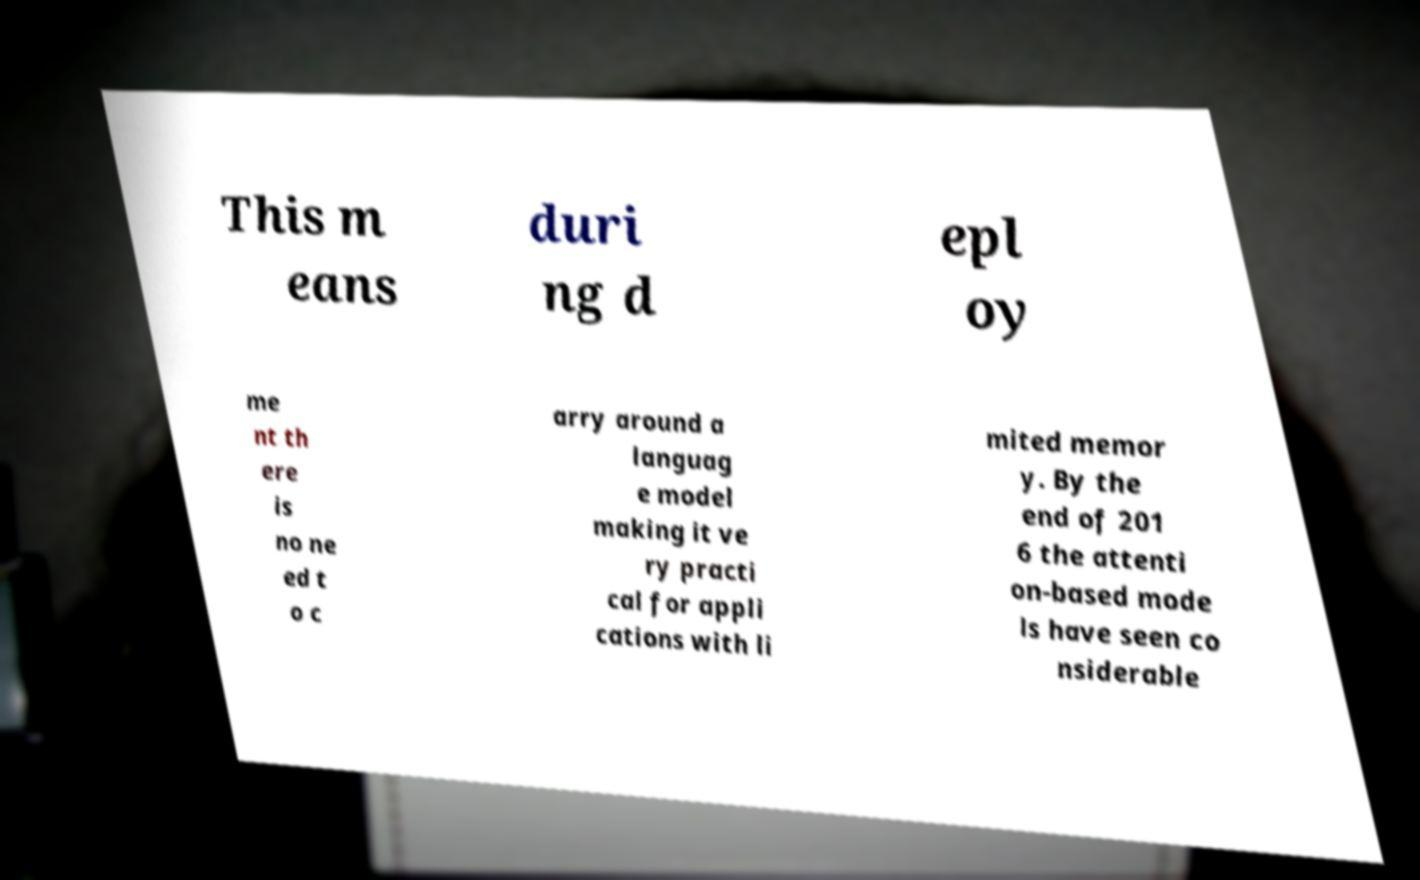Can you read and provide the text displayed in the image?This photo seems to have some interesting text. Can you extract and type it out for me? This m eans duri ng d epl oy me nt th ere is no ne ed t o c arry around a languag e model making it ve ry practi cal for appli cations with li mited memor y. By the end of 201 6 the attenti on-based mode ls have seen co nsiderable 